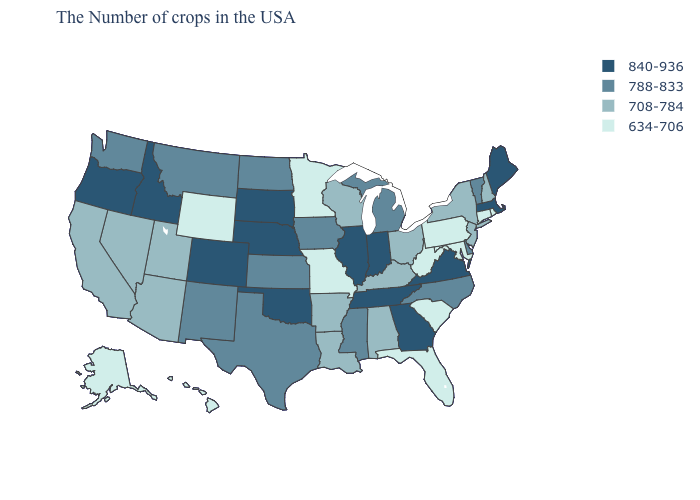Among the states that border Iowa , does South Dakota have the highest value?
Quick response, please. Yes. Does Missouri have the same value as Pennsylvania?
Short answer required. Yes. Which states have the lowest value in the Northeast?
Keep it brief. Rhode Island, Connecticut, Pennsylvania. What is the value of Florida?
Keep it brief. 634-706. What is the value of Virginia?
Short answer required. 840-936. Does Oregon have the highest value in the West?
Concise answer only. Yes. What is the value of Tennessee?
Quick response, please. 840-936. Does the first symbol in the legend represent the smallest category?
Write a very short answer. No. Among the states that border South Dakota , which have the highest value?
Concise answer only. Nebraska. Name the states that have a value in the range 788-833?
Be succinct. Vermont, Delaware, North Carolina, Michigan, Mississippi, Iowa, Kansas, Texas, North Dakota, New Mexico, Montana, Washington. What is the highest value in the USA?
Short answer required. 840-936. Name the states that have a value in the range 840-936?
Write a very short answer. Maine, Massachusetts, Virginia, Georgia, Indiana, Tennessee, Illinois, Nebraska, Oklahoma, South Dakota, Colorado, Idaho, Oregon. Does the map have missing data?
Concise answer only. No. What is the value of West Virginia?
Answer briefly. 634-706. 